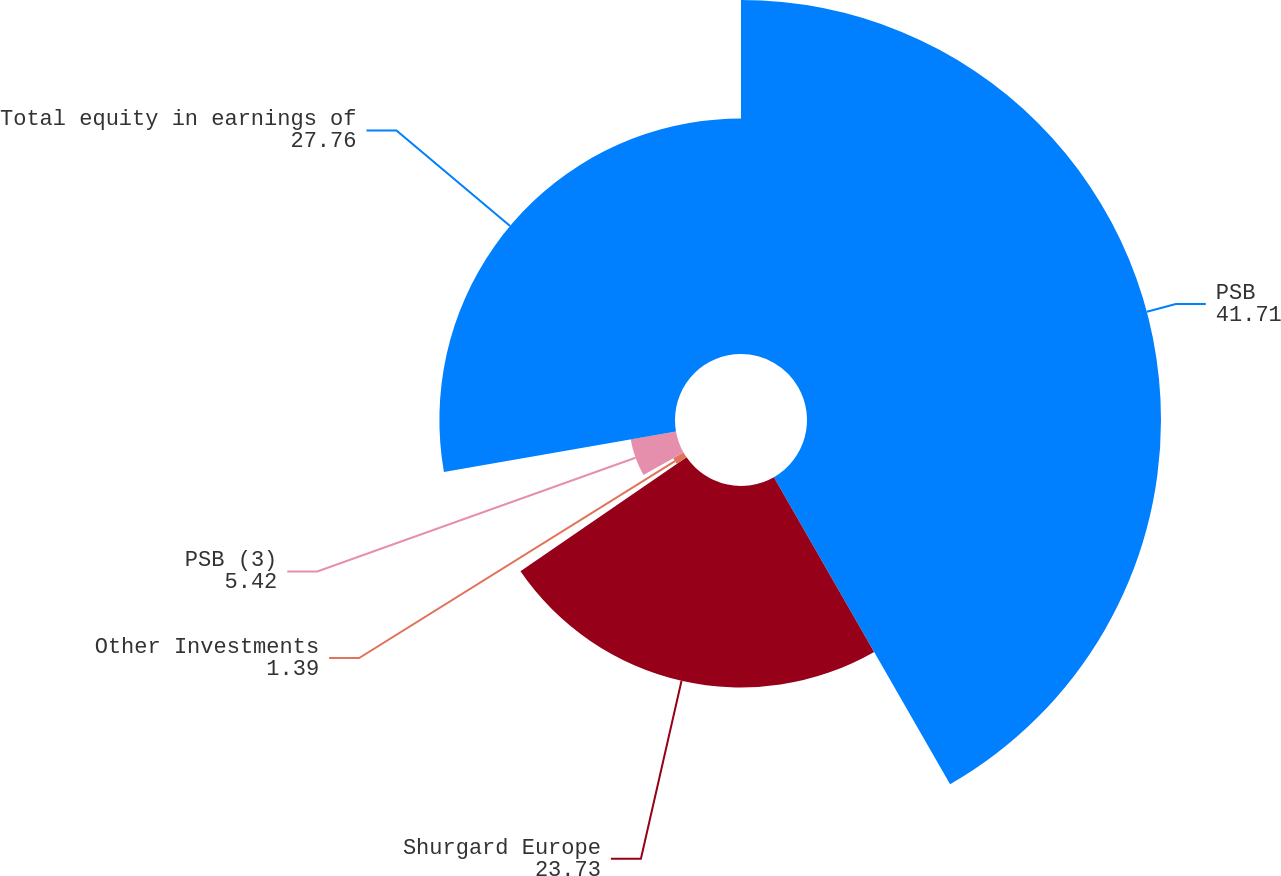Convert chart to OTSL. <chart><loc_0><loc_0><loc_500><loc_500><pie_chart><fcel>PSB<fcel>Shurgard Europe<fcel>Other Investments<fcel>PSB (3)<fcel>Total equity in earnings of<nl><fcel>41.71%<fcel>23.73%<fcel>1.39%<fcel>5.42%<fcel>27.76%<nl></chart> 